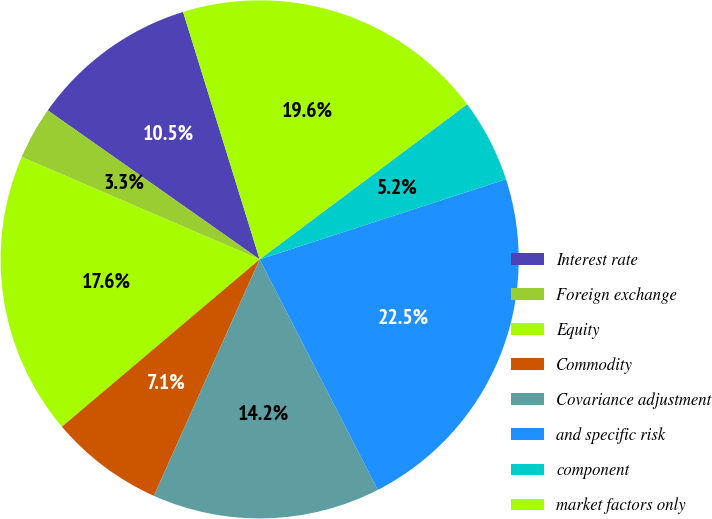<chart> <loc_0><loc_0><loc_500><loc_500><pie_chart><fcel>Interest rate<fcel>Foreign exchange<fcel>Equity<fcel>Commodity<fcel>Covariance adjustment<fcel>and specific risk<fcel>component<fcel>market factors only<nl><fcel>10.47%<fcel>3.29%<fcel>17.64%<fcel>7.13%<fcel>14.23%<fcel>22.47%<fcel>5.21%<fcel>19.56%<nl></chart> 